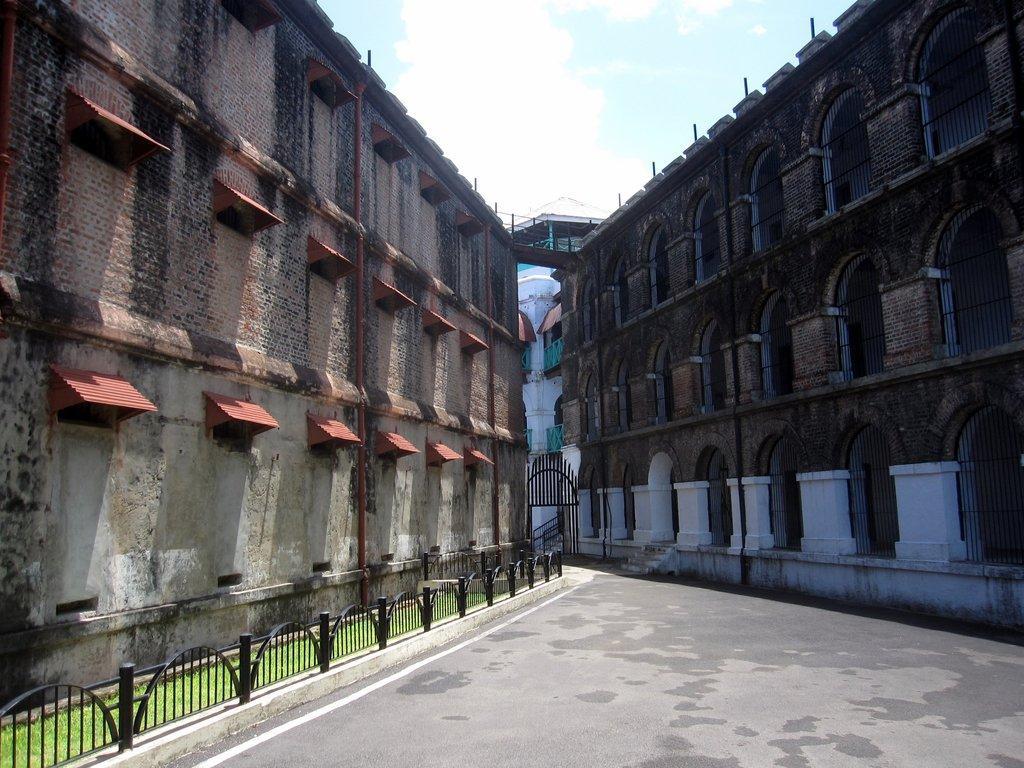Describe this image in one or two sentences. In this image we can see the cellular jail, one road, one black fence with poles, some grass on the surface, some poles, one black gate, one staircase, some sky blue color small fences, one small bridge connected the building and at the top there is the sky. 